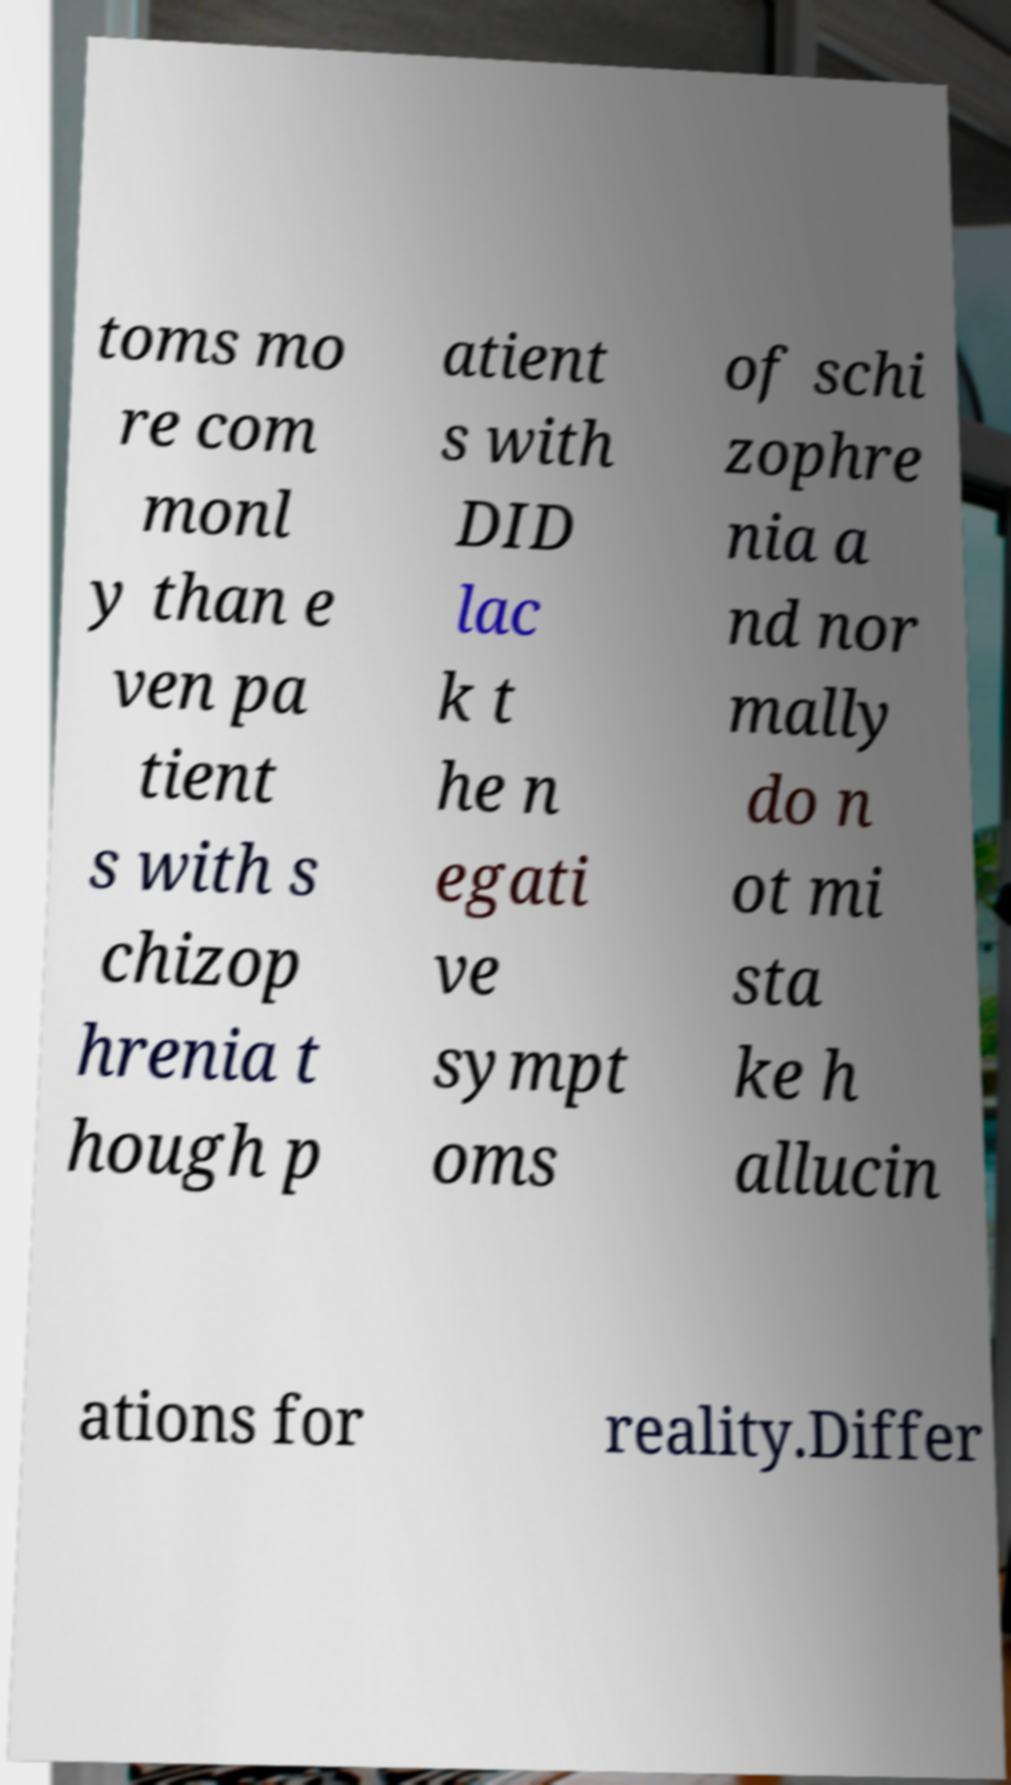Please read and relay the text visible in this image. What does it say? toms mo re com monl y than e ven pa tient s with s chizop hrenia t hough p atient s with DID lac k t he n egati ve sympt oms of schi zophre nia a nd nor mally do n ot mi sta ke h allucin ations for reality.Differ 